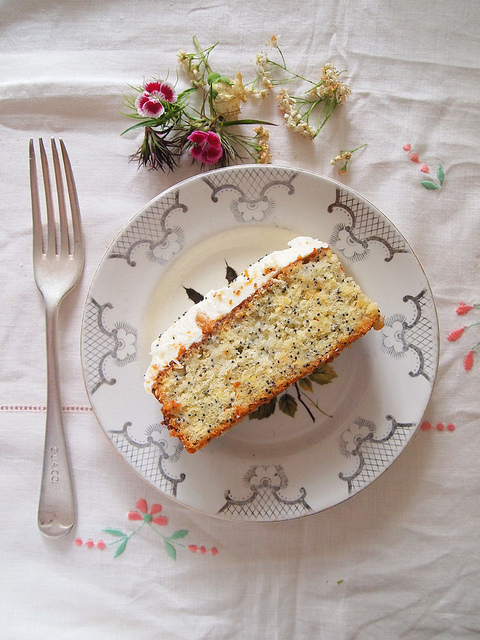How many flowers can you see in the flower arrangement? The image showcases an aesthetically pleasing flower arrangement. While the exact count of flowers is difficult to ascertain, it appears that there are multiple individual flowers creating a vibrant and lush display. 